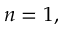<formula> <loc_0><loc_0><loc_500><loc_500>n = 1 ,</formula> 